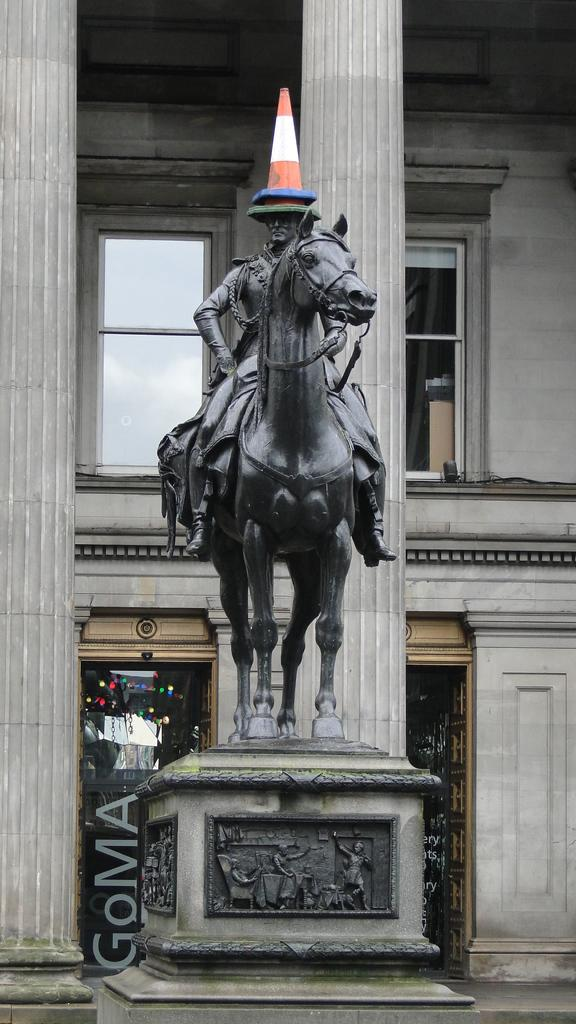What is the main subject of the image? There is a statue of a person sitting on a horse in the image. What is placed on the statue's head? The statue has a cone barricade on its head. What can be seen in the background of the image? There is a building with pillars in the background of the image. Can you tell me how many times the person on the horse is helping their brother in the image? There is no person or brother present in the image, as it only features a statue of a person sitting on a horse. 